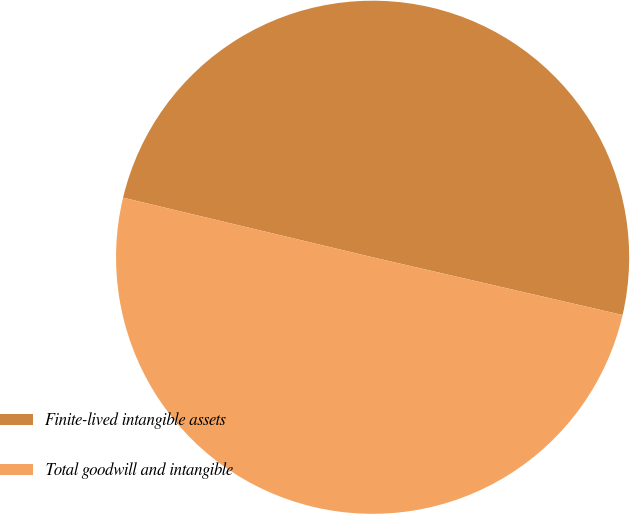Convert chart. <chart><loc_0><loc_0><loc_500><loc_500><pie_chart><fcel>Finite-lived intangible assets<fcel>Total goodwill and intangible<nl><fcel>49.88%<fcel>50.12%<nl></chart> 